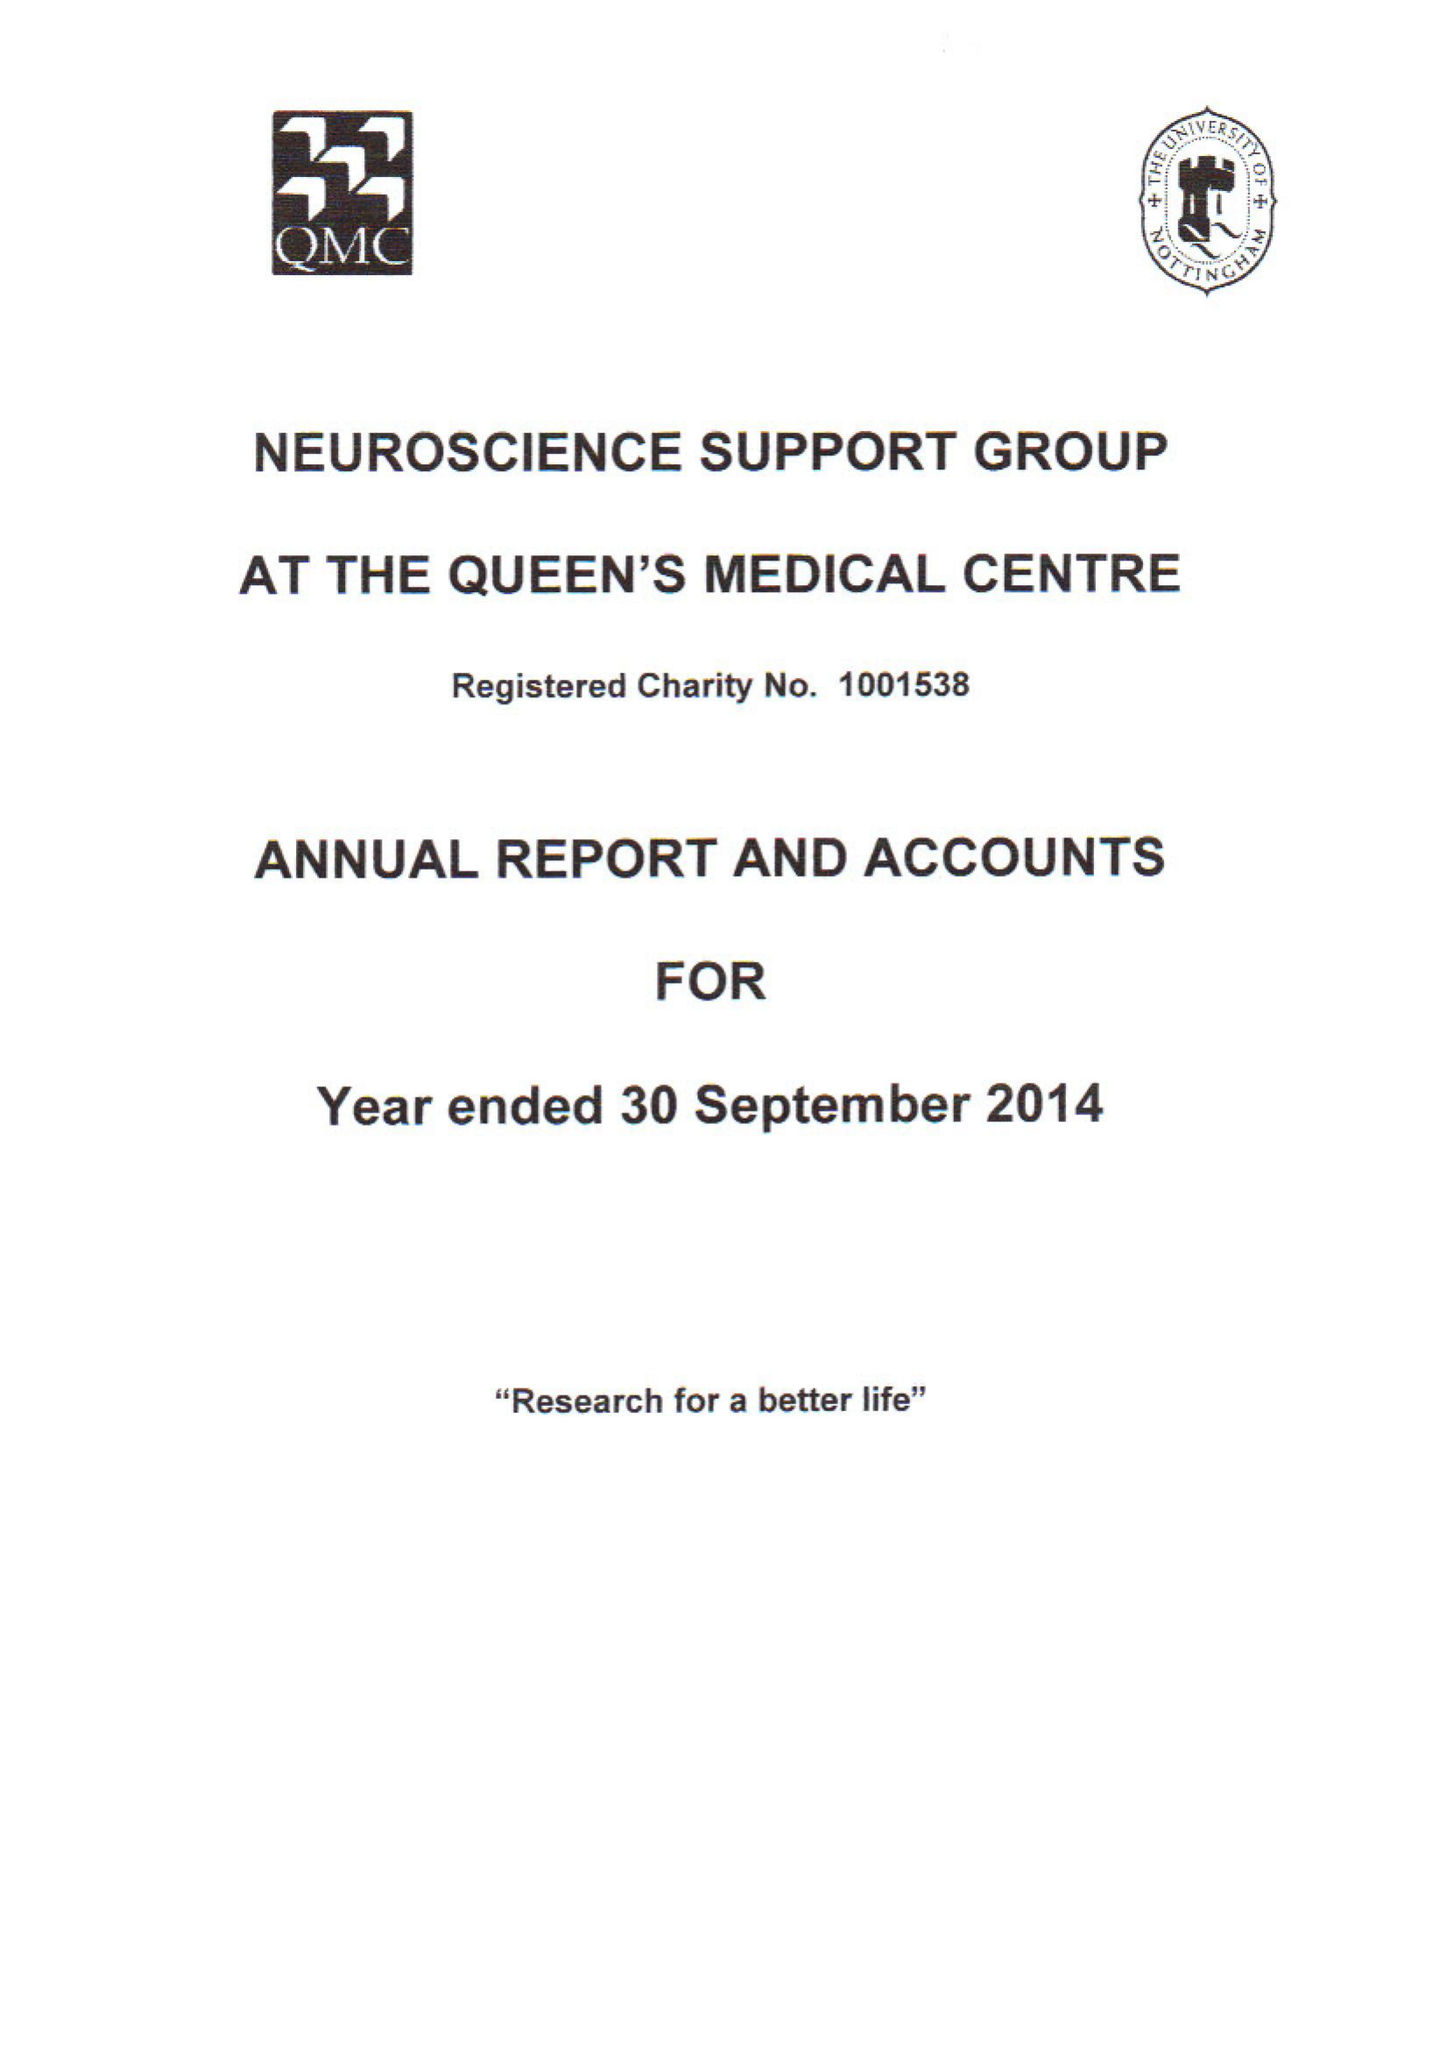What is the value for the address__postcode?
Answer the question using a single word or phrase. NG8 2FT 